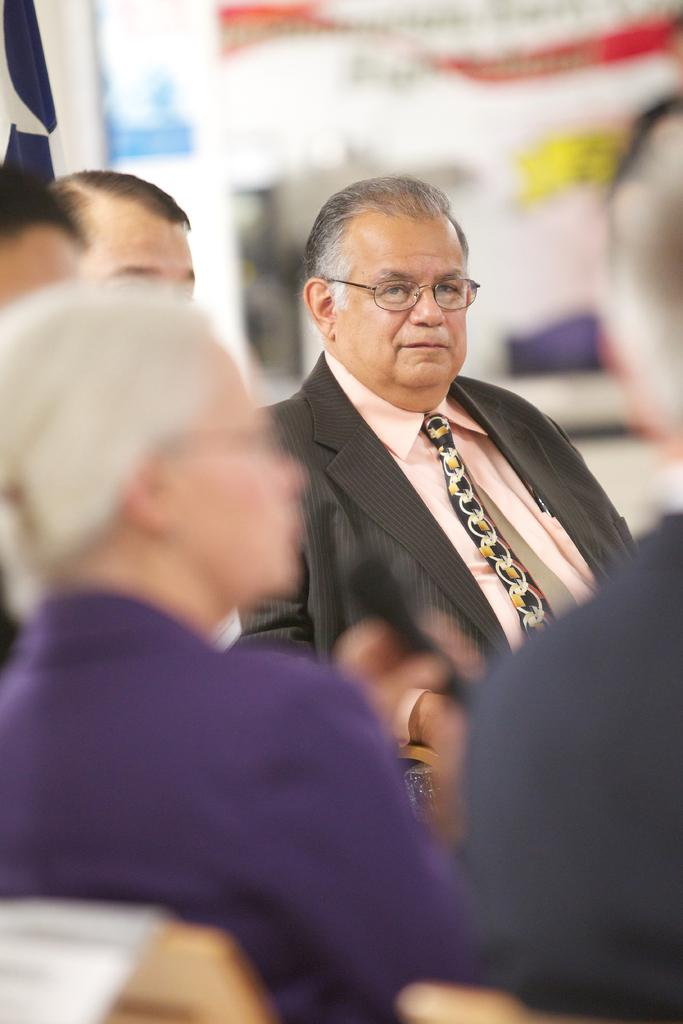Who or what is in the image? There are persons in the image. Where are the persons located in the image? The persons are in the front of the image. What can be observed about the background of the image? The background of the image is blurry. What type of feather is being offered by one of the persons in the image? There is no feather or offering present in the image; it only features persons in the front with a blurry background. 